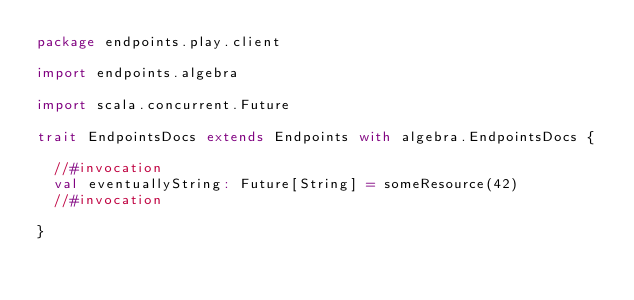Convert code to text. <code><loc_0><loc_0><loc_500><loc_500><_Scala_>package endpoints.play.client

import endpoints.algebra

import scala.concurrent.Future

trait EndpointsDocs extends Endpoints with algebra.EndpointsDocs {

  //#invocation
  val eventuallyString: Future[String] = someResource(42)
  //#invocation

}
</code> 